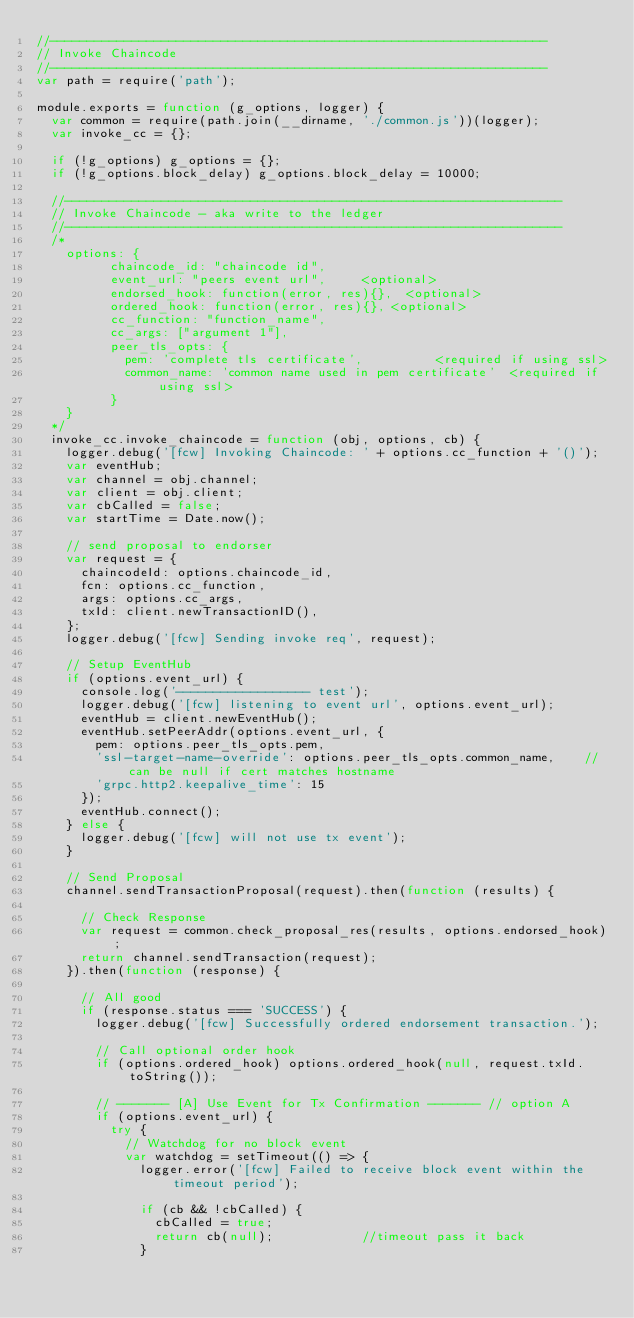Convert code to text. <code><loc_0><loc_0><loc_500><loc_500><_JavaScript_>//-------------------------------------------------------------------
// Invoke Chaincode
//-------------------------------------------------------------------
var path = require('path');

module.exports = function (g_options, logger) {
	var common = require(path.join(__dirname, './common.js'))(logger);
	var invoke_cc = {};

	if (!g_options) g_options = {};
	if (!g_options.block_delay) g_options.block_delay = 10000;

	//-------------------------------------------------------------------
	// Invoke Chaincode - aka write to the ledger
	//-------------------------------------------------------------------
	/*
		options: {
					chaincode_id: "chaincode id",
					event_url: "peers event url",			<optional>
					endorsed_hook: function(error, res){},	<optional>
					ordered_hook: function(error, res){},	<optional>
					cc_function: "function_name",
					cc_args: ["argument 1"],
					peer_tls_opts: {
						pem: 'complete tls certificate',					<required if using ssl>
						common_name: 'common name used in pem certificate' 	<required if using ssl>
					}
		}
	*/
	invoke_cc.invoke_chaincode = function (obj, options, cb) {
		logger.debug('[fcw] Invoking Chaincode: ' + options.cc_function + '()');
		var eventHub;
		var channel = obj.channel;
		var client = obj.client;
		var cbCalled = false;
		var startTime = Date.now();

		// send proposal to endorser
		var request = {
			chaincodeId: options.chaincode_id,
			fcn: options.cc_function,
			args: options.cc_args,
			txId: client.newTransactionID(),
		};
		logger.debug('[fcw] Sending invoke req', request);

		// Setup EventHub
		if (options.event_url) {
			console.log('------------------ test');
			logger.debug('[fcw] listening to event url', options.event_url);
			eventHub = client.newEventHub();
			eventHub.setPeerAddr(options.event_url, {
				pem: options.peer_tls_opts.pem,
				'ssl-target-name-override': options.peer_tls_opts.common_name,		//can be null if cert matches hostname
				'grpc.http2.keepalive_time': 15
			});
			eventHub.connect();
		} else {
			logger.debug('[fcw] will not use tx event');
		}

		// Send Proposal
		channel.sendTransactionProposal(request).then(function (results) {

			// Check Response
			var request = common.check_proposal_res(results, options.endorsed_hook);
			return channel.sendTransaction(request);
		}).then(function (response) {

			// All good
			if (response.status === 'SUCCESS') {
				logger.debug('[fcw] Successfully ordered endorsement transaction.');

				// Call optional order hook
				if (options.ordered_hook) options.ordered_hook(null, request.txId.toString());

				// ------- [A] Use Event for Tx Confirmation ------- // option A
				if (options.event_url) {
					try {
						// Watchdog for no block event
						var watchdog = setTimeout(() => {
							logger.error('[fcw] Failed to receive block event within the timeout period');

							if (cb && !cbCalled) {
								cbCalled = true;
								return cb(null);						//timeout pass it back
							}</code> 